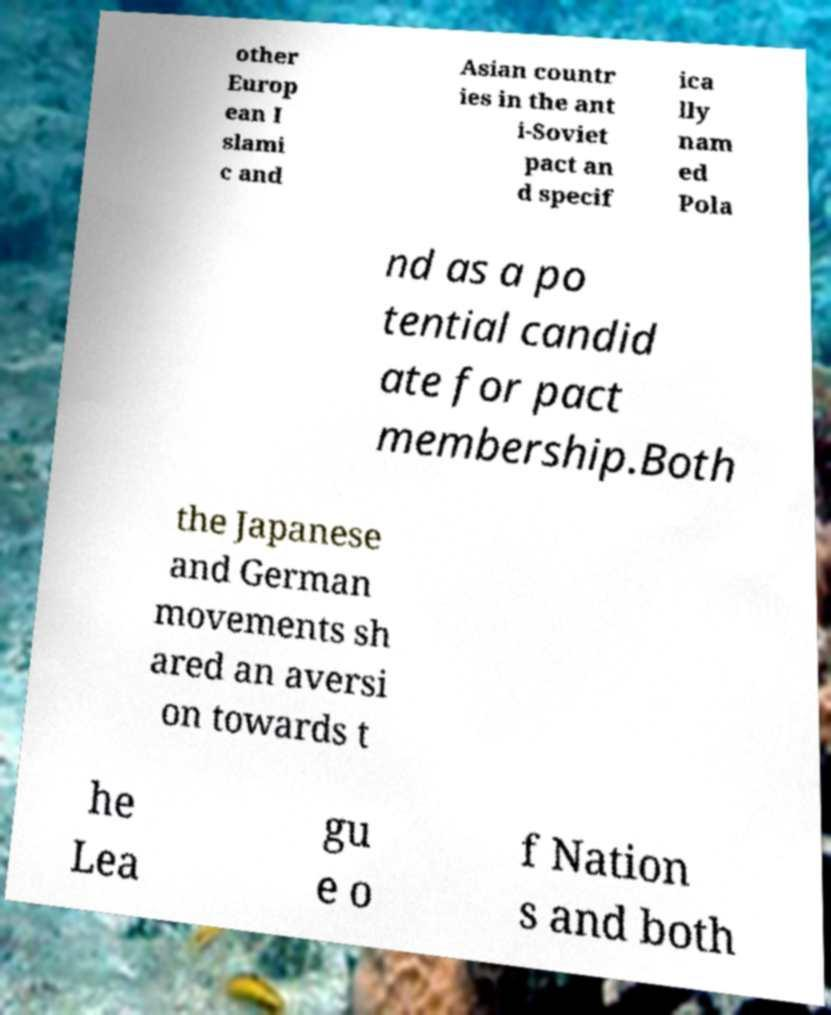Could you assist in decoding the text presented in this image and type it out clearly? other Europ ean I slami c and Asian countr ies in the ant i-Soviet pact an d specif ica lly nam ed Pola nd as a po tential candid ate for pact membership.Both the Japanese and German movements sh ared an aversi on towards t he Lea gu e o f Nation s and both 